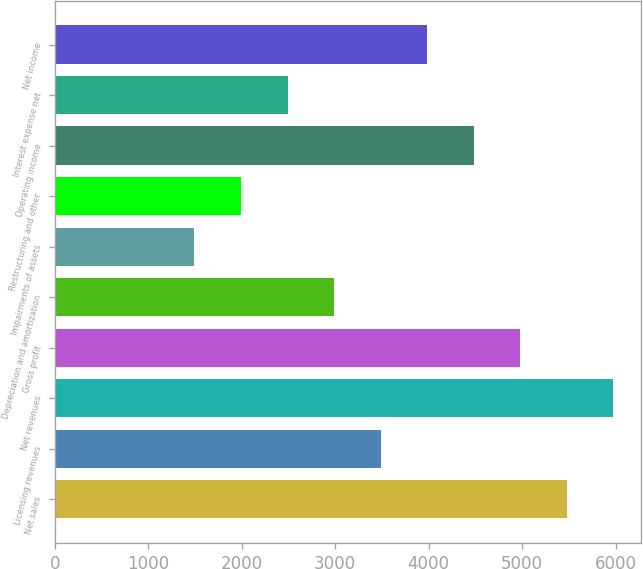Convert chart. <chart><loc_0><loc_0><loc_500><loc_500><bar_chart><fcel>Net sales<fcel>Licensing revenues<fcel>Net revenues<fcel>Gross profit<fcel>Depreciation and amortization<fcel>Impairments of assets<fcel>Restructuring and other<fcel>Operating income<fcel>Interest expense net<fcel>Net income<nl><fcel>5476.87<fcel>3485.39<fcel>5974.74<fcel>4979<fcel>2987.52<fcel>1493.91<fcel>1991.78<fcel>4481.13<fcel>2489.65<fcel>3983.26<nl></chart> 